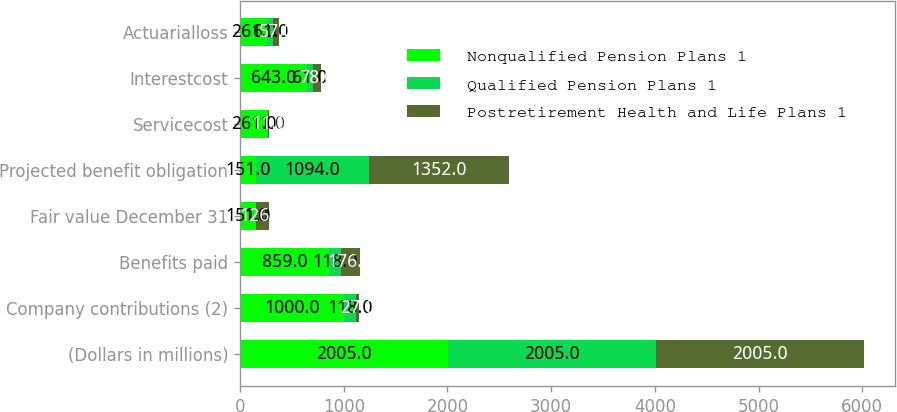<chart> <loc_0><loc_0><loc_500><loc_500><stacked_bar_chart><ecel><fcel>(Dollars in millions)<fcel>Company contributions (2)<fcel>Benefits paid<fcel>Fair value December 31<fcel>Projected benefit obligation<fcel>Servicecost<fcel>Interestcost<fcel>Actuarialloss<nl><fcel>Nonqualified Pension Plans 1<fcel>2005<fcel>1000<fcel>859<fcel>151<fcel>151<fcel>261<fcel>643<fcel>261<nl><fcel>Qualified Pension Plans 1<fcel>2005<fcel>118<fcel>118<fcel>1<fcel>1094<fcel>11<fcel>61<fcel>61<nl><fcel>Postretirement Health and Life Plans 1<fcel>2005<fcel>27<fcel>176<fcel>126<fcel>1352<fcel>11<fcel>78<fcel>57<nl></chart> 